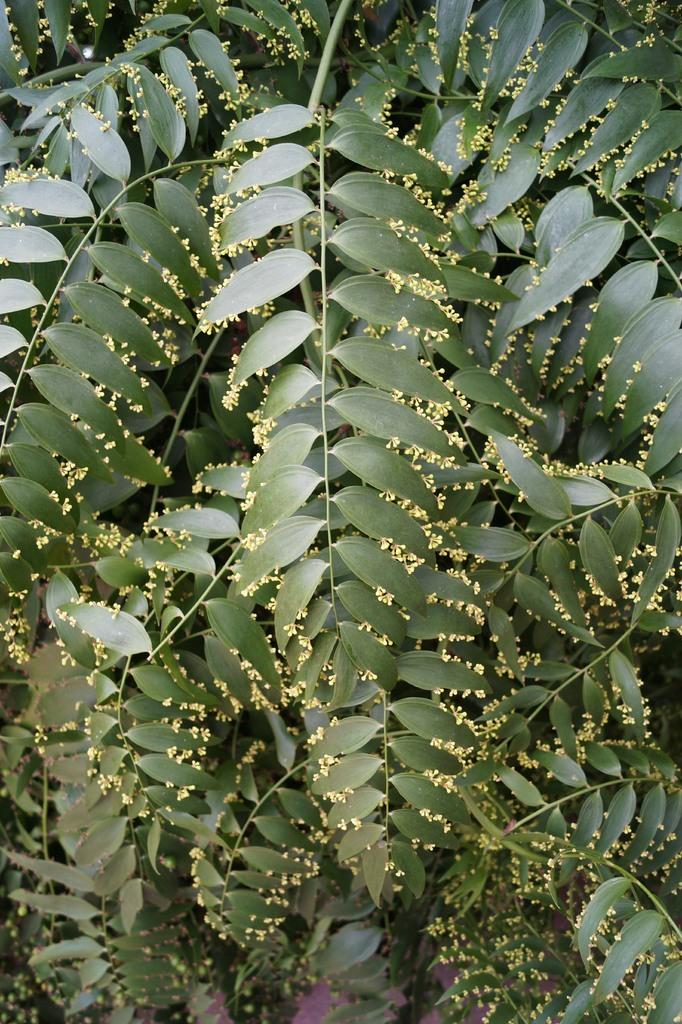What type of plant can be seen in the image? There is a tree in the image. What type of fiction is the tree holding in its branches in the image? There is no fiction present in the image, as trees do not hold or interact with books or other forms of literature. 